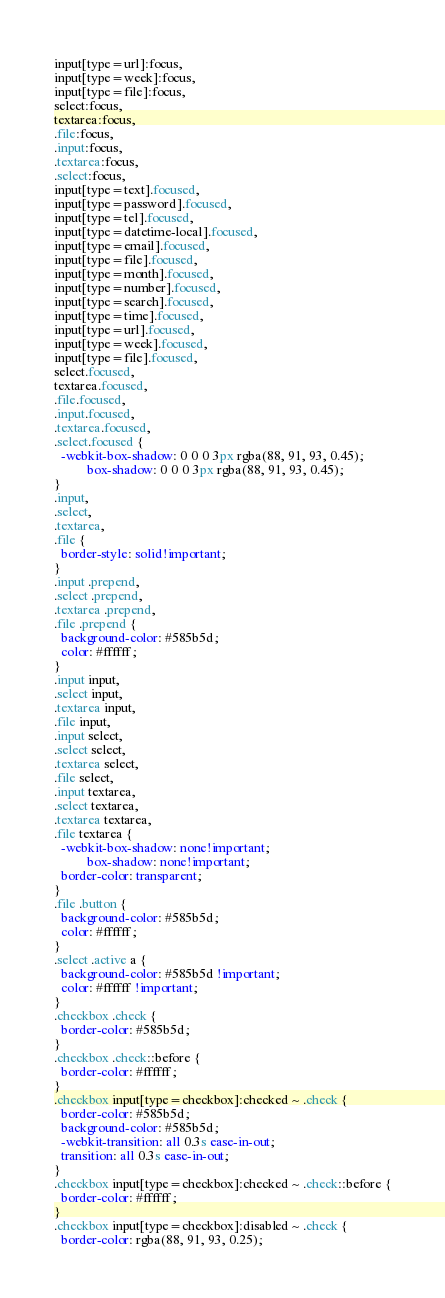Convert code to text. <code><loc_0><loc_0><loc_500><loc_500><_CSS_>input[type=url]:focus,
input[type=week]:focus,
input[type=file]:focus,
select:focus,
textarea:focus,
.file:focus,
.input:focus,
.textarea:focus,
.select:focus,
input[type=text].focused,
input[type=password].focused,
input[type=tel].focused,
input[type=datetime-local].focused,
input[type=email].focused,
input[type=file].focused,
input[type=month].focused,
input[type=number].focused,
input[type=search].focused,
input[type=time].focused,
input[type=url].focused,
input[type=week].focused,
input[type=file].focused,
select.focused,
textarea.focused,
.file.focused,
.input.focused,
.textarea.focused,
.select.focused {
  -webkit-box-shadow: 0 0 0 3px rgba(88, 91, 93, 0.45);
          box-shadow: 0 0 0 3px rgba(88, 91, 93, 0.45);
}
.input,
.select,
.textarea,
.file {
  border-style: solid!important;
}
.input .prepend,
.select .prepend,
.textarea .prepend,
.file .prepend {
  background-color: #585b5d;
  color: #ffffff;
}
.input input,
.select input,
.textarea input,
.file input,
.input select,
.select select,
.textarea select,
.file select,
.input textarea,
.select textarea,
.textarea textarea,
.file textarea {
  -webkit-box-shadow: none!important;
          box-shadow: none!important;
  border-color: transparent;
}
.file .button {
  background-color: #585b5d;
  color: #ffffff;
}
.select .active a {
  background-color: #585b5d !important;
  color: #ffffff !important;
}
.checkbox .check {
  border-color: #585b5d;
}
.checkbox .check::before {
  border-color: #ffffff;
}
.checkbox input[type=checkbox]:checked ~ .check {
  border-color: #585b5d;
  background-color: #585b5d;
  -webkit-transition: all 0.3s ease-in-out;
  transition: all 0.3s ease-in-out;
}
.checkbox input[type=checkbox]:checked ~ .check::before {
  border-color: #ffffff;
}
.checkbox input[type=checkbox]:disabled ~ .check {
  border-color: rgba(88, 91, 93, 0.25);</code> 